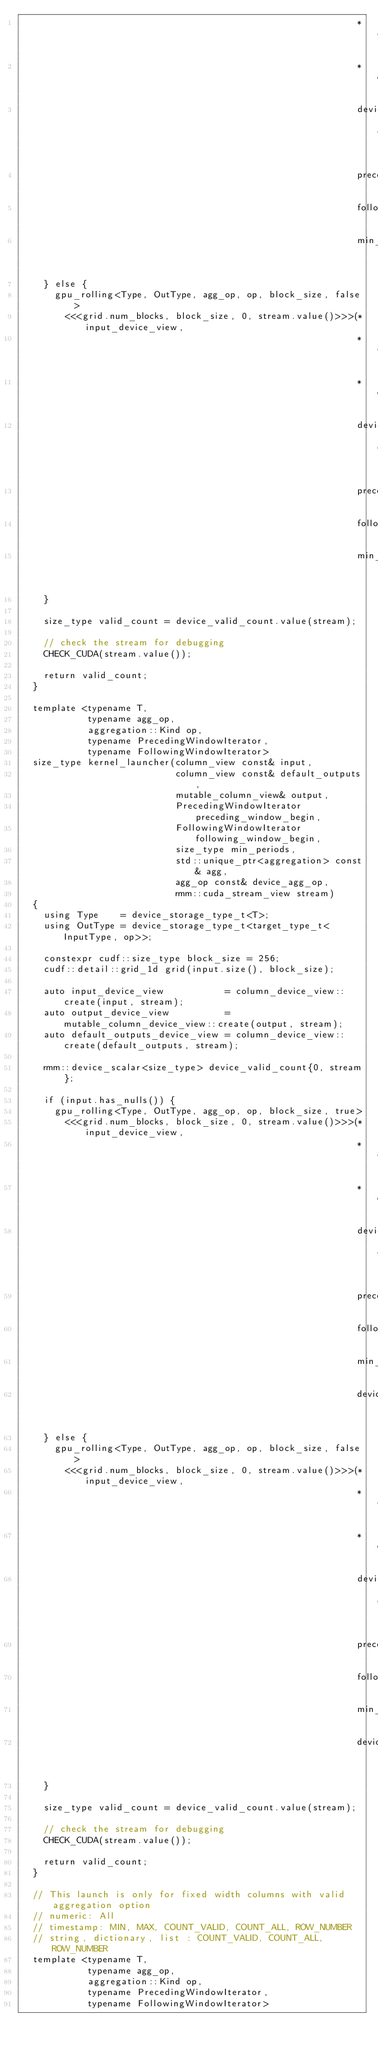Convert code to text. <code><loc_0><loc_0><loc_500><loc_500><_Cuda_>                                                             *default_outputs_device_view,
                                                             *output_device_view,
                                                             device_valid_count.data(),
                                                             preceding_window_begin,
                                                             following_window_begin,
                                                             min_periods);
    } else {
      gpu_rolling<Type, OutType, agg_op, op, block_size, false>
        <<<grid.num_blocks, block_size, 0, stream.value()>>>(*input_device_view,
                                                             *default_outputs_device_view,
                                                             *output_device_view,
                                                             device_valid_count.data(),
                                                             preceding_window_begin,
                                                             following_window_begin,
                                                             min_periods);
    }

    size_type valid_count = device_valid_count.value(stream);

    // check the stream for debugging
    CHECK_CUDA(stream.value());

    return valid_count;
  }

  template <typename T,
            typename agg_op,
            aggregation::Kind op,
            typename PrecedingWindowIterator,
            typename FollowingWindowIterator>
  size_type kernel_launcher(column_view const& input,
                            column_view const& default_outputs,
                            mutable_column_view& output,
                            PrecedingWindowIterator preceding_window_begin,
                            FollowingWindowIterator following_window_begin,
                            size_type min_periods,
                            std::unique_ptr<aggregation> const& agg,
                            agg_op const& device_agg_op,
                            rmm::cuda_stream_view stream)
  {
    using Type    = device_storage_type_t<T>;
    using OutType = device_storage_type_t<target_type_t<InputType, op>>;

    constexpr cudf::size_type block_size = 256;
    cudf::detail::grid_1d grid(input.size(), block_size);

    auto input_device_view           = column_device_view::create(input, stream);
    auto output_device_view          = mutable_column_device_view::create(output, stream);
    auto default_outputs_device_view = column_device_view::create(default_outputs, stream);

    rmm::device_scalar<size_type> device_valid_count{0, stream};

    if (input.has_nulls()) {
      gpu_rolling<Type, OutType, agg_op, op, block_size, true>
        <<<grid.num_blocks, block_size, 0, stream.value()>>>(*input_device_view,
                                                             *default_outputs_device_view,
                                                             *output_device_view,
                                                             device_valid_count.data(),
                                                             preceding_window_begin,
                                                             following_window_begin,
                                                             min_periods,
                                                             device_agg_op);
    } else {
      gpu_rolling<Type, OutType, agg_op, op, block_size, false>
        <<<grid.num_blocks, block_size, 0, stream.value()>>>(*input_device_view,
                                                             *default_outputs_device_view,
                                                             *output_device_view,
                                                             device_valid_count.data(),
                                                             preceding_window_begin,
                                                             following_window_begin,
                                                             min_periods,
                                                             device_agg_op);
    }

    size_type valid_count = device_valid_count.value(stream);

    // check the stream for debugging
    CHECK_CUDA(stream.value());

    return valid_count;
  }

  // This launch is only for fixed width columns with valid aggregation option
  // numeric: All
  // timestamp: MIN, MAX, COUNT_VALID, COUNT_ALL, ROW_NUMBER
  // string, dictionary, list : COUNT_VALID, COUNT_ALL, ROW_NUMBER
  template <typename T,
            typename agg_op,
            aggregation::Kind op,
            typename PrecedingWindowIterator,
            typename FollowingWindowIterator></code> 